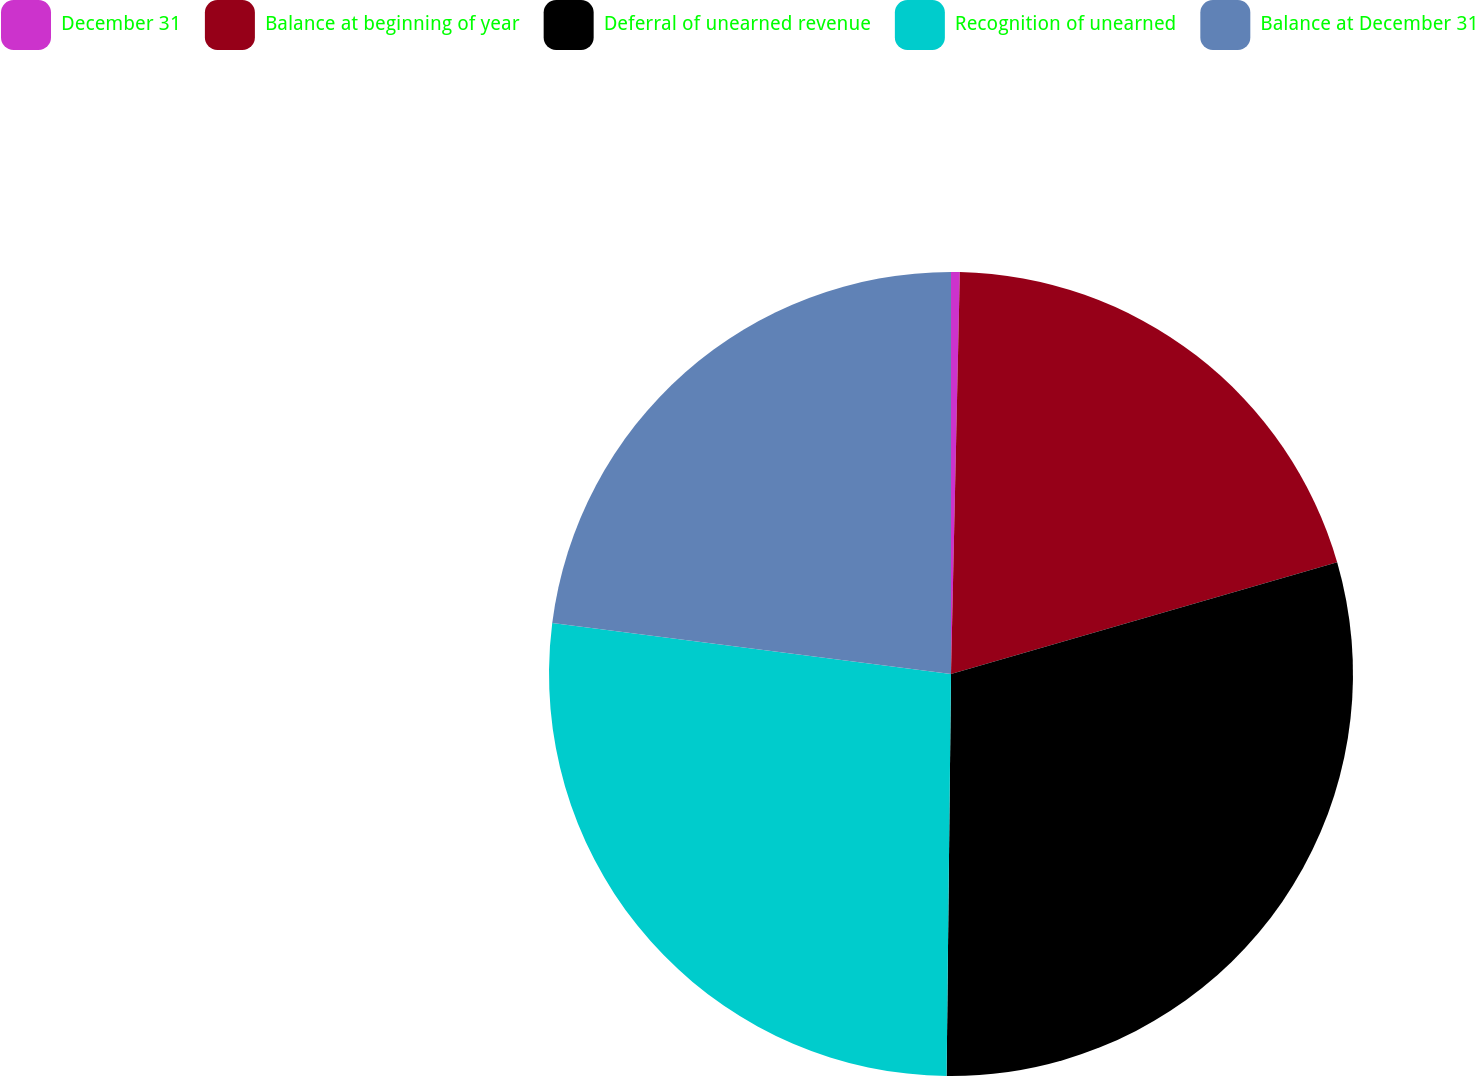Convert chart. <chart><loc_0><loc_0><loc_500><loc_500><pie_chart><fcel>December 31<fcel>Balance at beginning of year<fcel>Deferral of unearned revenue<fcel>Recognition of unearned<fcel>Balance at December 31<nl><fcel>0.35%<fcel>20.17%<fcel>29.66%<fcel>26.85%<fcel>22.98%<nl></chart> 